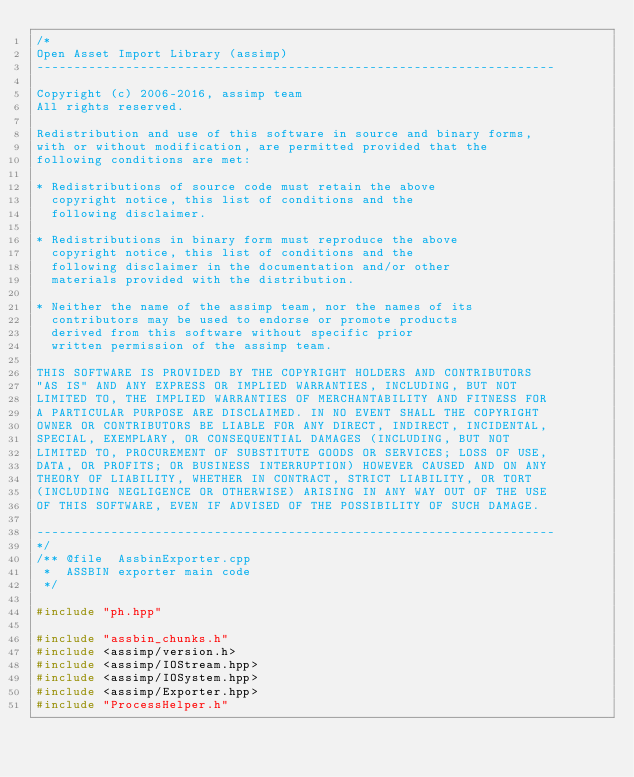<code> <loc_0><loc_0><loc_500><loc_500><_C++_>/*
Open Asset Import Library (assimp)
----------------------------------------------------------------------

Copyright (c) 2006-2016, assimp team
All rights reserved.

Redistribution and use of this software in source and binary forms,
with or without modification, are permitted provided that the
following conditions are met:

* Redistributions of source code must retain the above
  copyright notice, this list of conditions and the
  following disclaimer.

* Redistributions in binary form must reproduce the above
  copyright notice, this list of conditions and the
  following disclaimer in the documentation and/or other
  materials provided with the distribution.

* Neither the name of the assimp team, nor the names of its
  contributors may be used to endorse or promote products
  derived from this software without specific prior
  written permission of the assimp team.

THIS SOFTWARE IS PROVIDED BY THE COPYRIGHT HOLDERS AND CONTRIBUTORS
"AS IS" AND ANY EXPRESS OR IMPLIED WARRANTIES, INCLUDING, BUT NOT
LIMITED TO, THE IMPLIED WARRANTIES OF MERCHANTABILITY AND FITNESS FOR
A PARTICULAR PURPOSE ARE DISCLAIMED. IN NO EVENT SHALL THE COPYRIGHT
OWNER OR CONTRIBUTORS BE LIABLE FOR ANY DIRECT, INDIRECT, INCIDENTAL,
SPECIAL, EXEMPLARY, OR CONSEQUENTIAL DAMAGES (INCLUDING, BUT NOT
LIMITED TO, PROCUREMENT OF SUBSTITUTE GOODS OR SERVICES; LOSS OF USE,
DATA, OR PROFITS; OR BUSINESS INTERRUPTION) HOWEVER CAUSED AND ON ANY
THEORY OF LIABILITY, WHETHER IN CONTRACT, STRICT LIABILITY, OR TORT
(INCLUDING NEGLIGENCE OR OTHERWISE) ARISING IN ANY WAY OUT OF THE USE
OF THIS SOFTWARE, EVEN IF ADVISED OF THE POSSIBILITY OF SUCH DAMAGE.

----------------------------------------------------------------------
*/
/** @file  AssbinExporter.cpp
 *  ASSBIN exporter main code
 */

#include "ph.hpp"

#include "assbin_chunks.h"
#include <assimp/version.h>
#include <assimp/IOStream.hpp>
#include <assimp/IOSystem.hpp>
#include <assimp/Exporter.hpp>
#include "ProcessHelper.h"</code> 